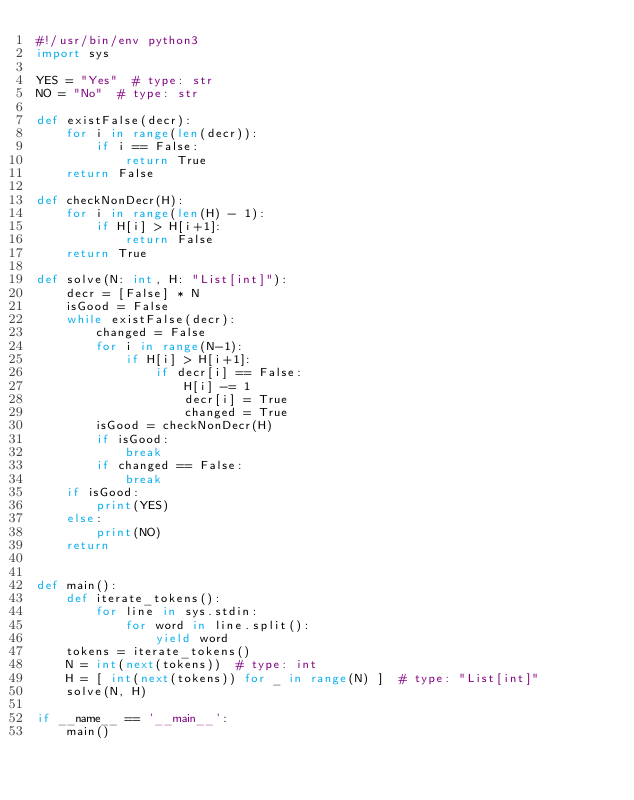Convert code to text. <code><loc_0><loc_0><loc_500><loc_500><_Python_>#!/usr/bin/env python3
import sys

YES = "Yes"  # type: str
NO = "No"  # type: str

def existFalse(decr):
    for i in range(len(decr)):
        if i == False:
            return True
    return False

def checkNonDecr(H):
    for i in range(len(H) - 1):
        if H[i] > H[i+1]:
            return False
    return True

def solve(N: int, H: "List[int]"):
    decr = [False] * N
    isGood = False
    while existFalse(decr):
        changed = False
        for i in range(N-1):
            if H[i] > H[i+1]:
                if decr[i] == False:
                    H[i] -= 1
                    decr[i] = True
                    changed = True
        isGood = checkNonDecr(H)
        if isGood: 
            break
        if changed == False:
            break
    if isGood:
        print(YES)
    else:
        print(NO)
    return


def main():
    def iterate_tokens():
        for line in sys.stdin:
            for word in line.split():
                yield word
    tokens = iterate_tokens()
    N = int(next(tokens))  # type: int
    H = [ int(next(tokens)) for _ in range(N) ]  # type: "List[int]"
    solve(N, H)

if __name__ == '__main__':
    main()
</code> 